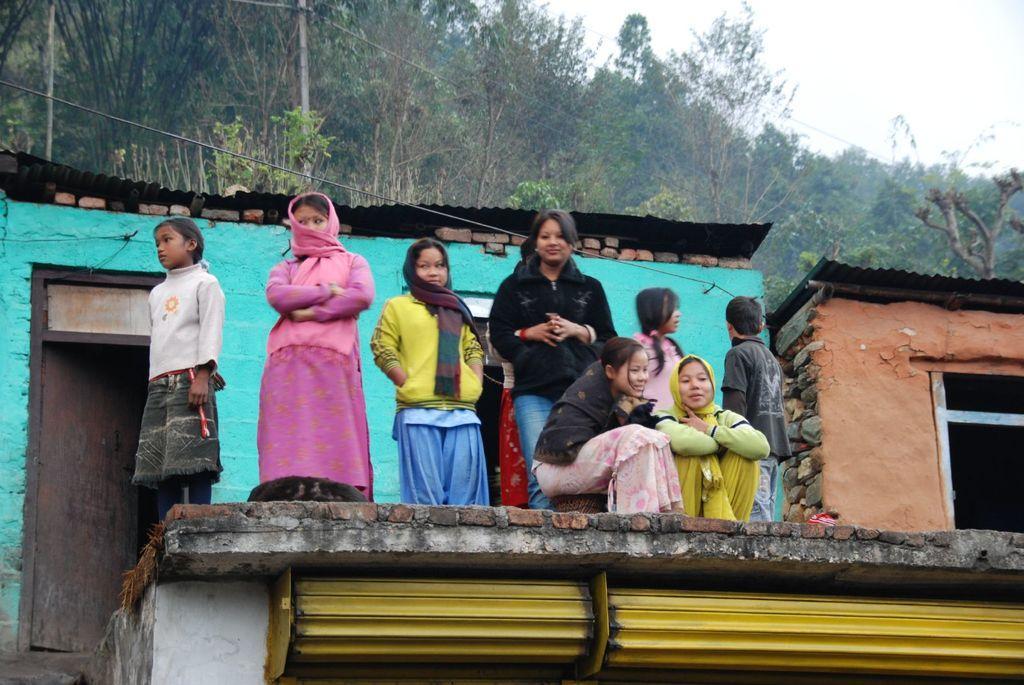How would you summarize this image in a sentence or two? In this image I can see few persons are standing on the on the concrete surface and few of them are sitting. I can see yellow colored rolling shutter, the blue colored house, the door and few trees. In the background I can see the sky. 